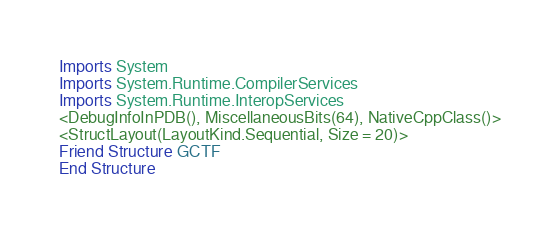<code> <loc_0><loc_0><loc_500><loc_500><_VisualBasic_>Imports System
Imports System.Runtime.CompilerServices
Imports System.Runtime.InteropServices
<DebugInfoInPDB(), MiscellaneousBits(64), NativeCppClass()>
<StructLayout(LayoutKind.Sequential, Size = 20)>
Friend Structure GCTF
End Structure
</code> 